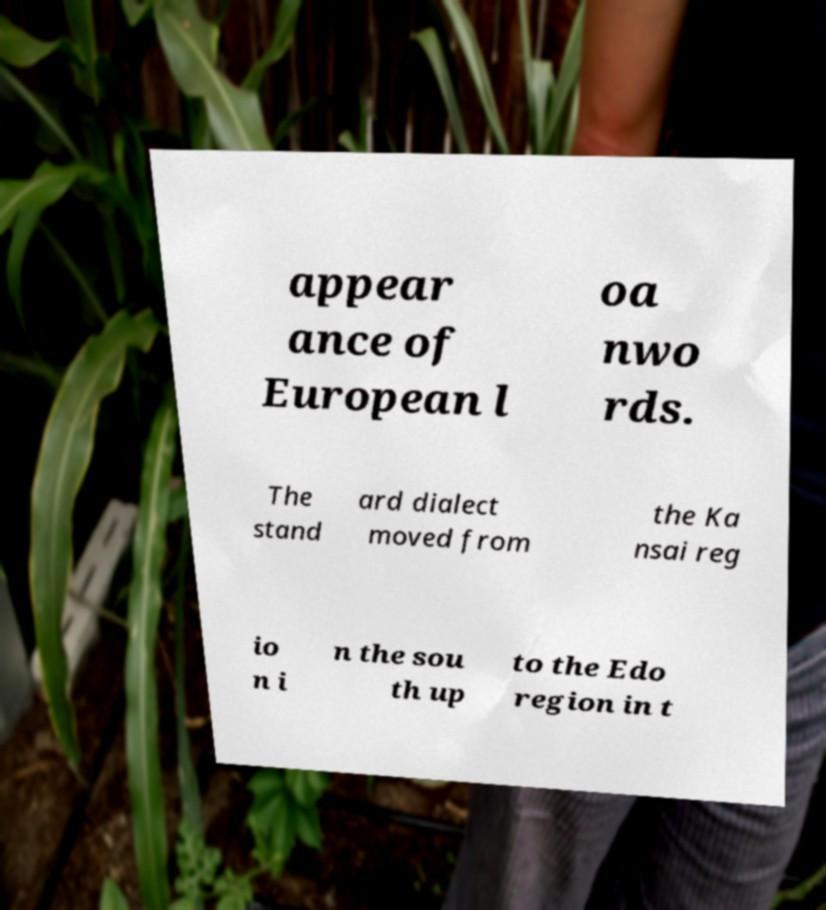Please identify and transcribe the text found in this image. appear ance of European l oa nwo rds. The stand ard dialect moved from the Ka nsai reg io n i n the sou th up to the Edo region in t 